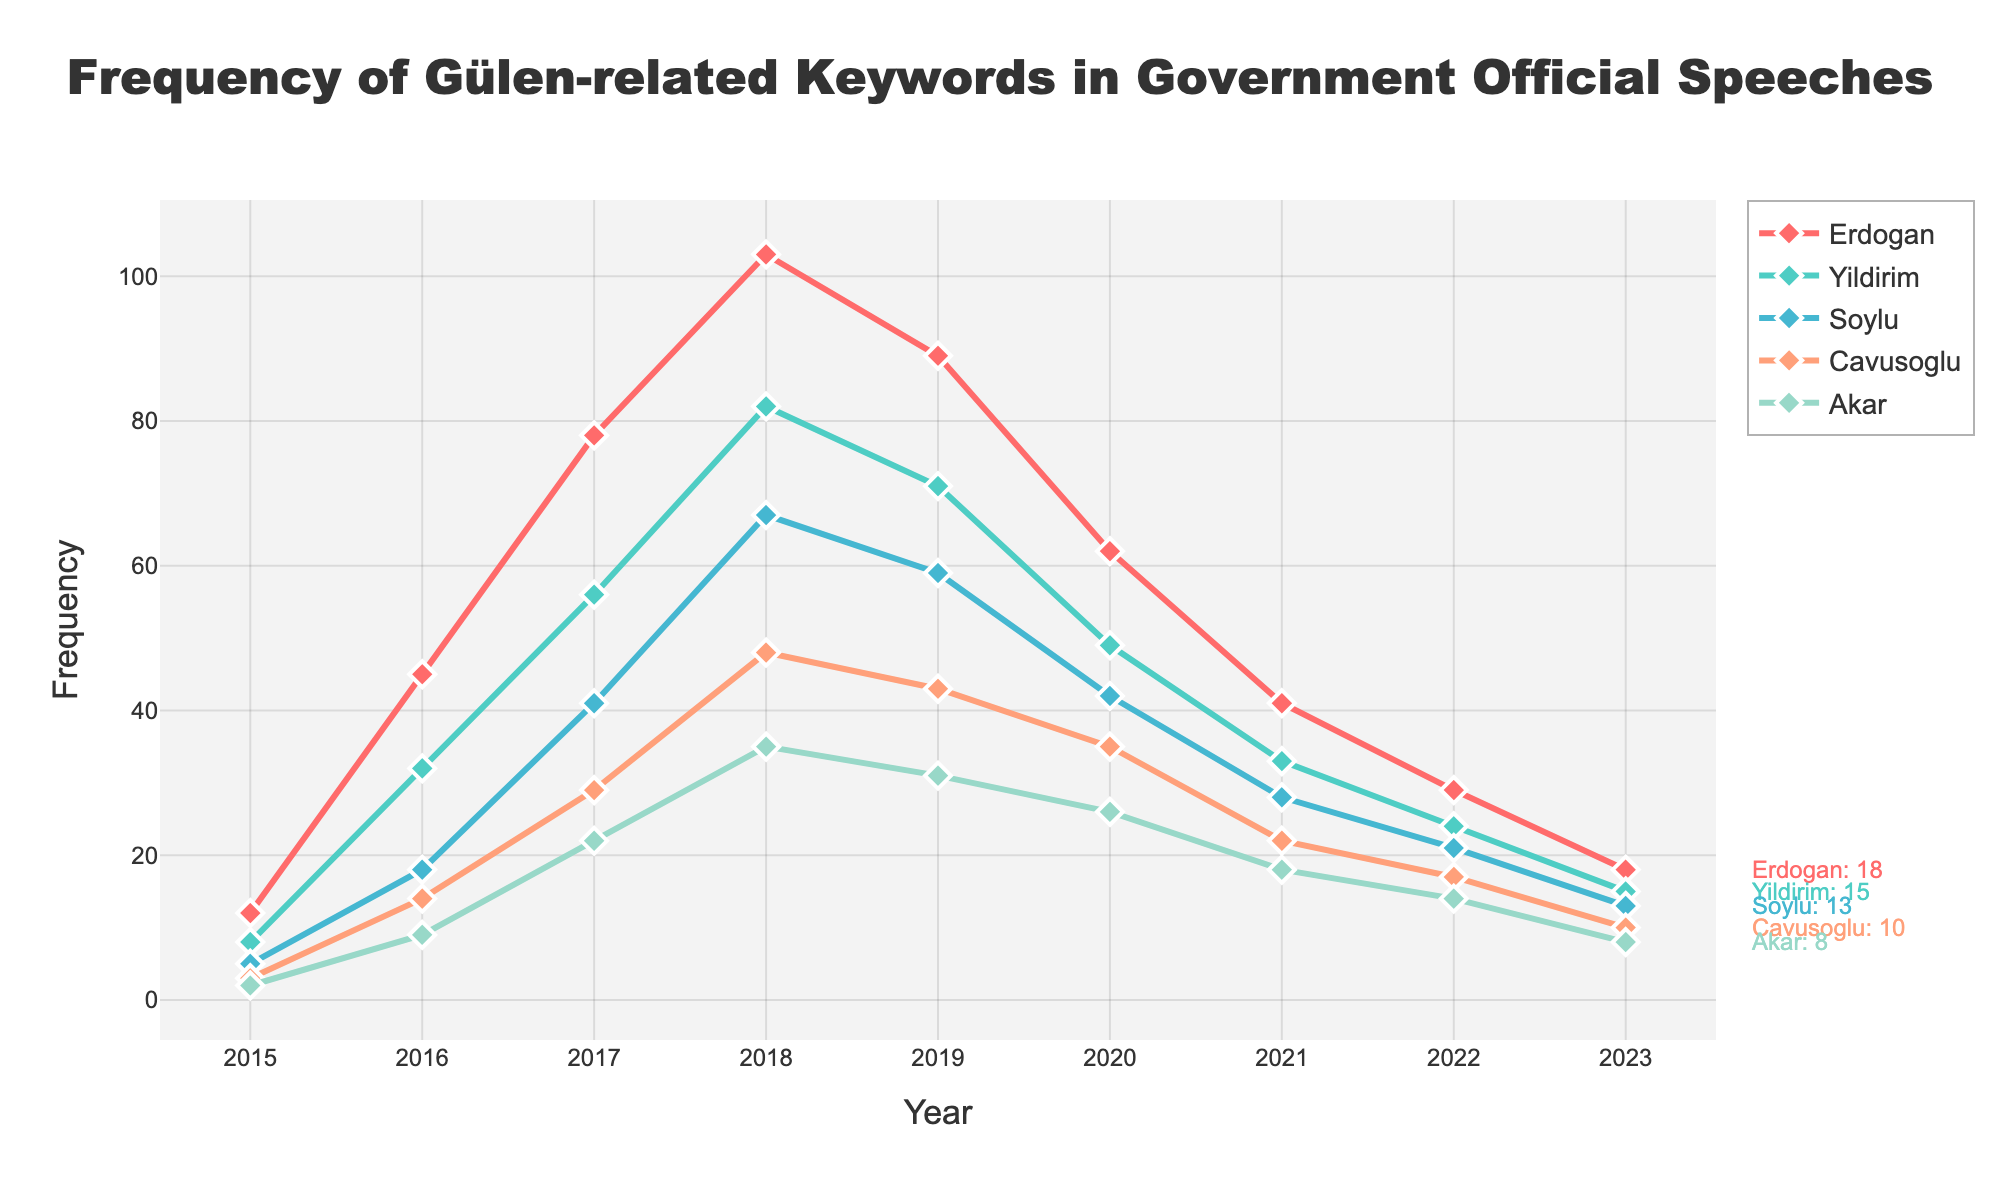What's the overall trend in the frequency of Gülen-related keywords in government official speeches from 2015 to 2023? The frequency of Gülen-related keywords increased from 2015 to 2018 before declining steadily from 2019 to 2023.
Answer: Increased till 2018, then declined Which official mentioned Gülen-related keywords the most in 2018? By looking at the highest point in the lines for 2018, we can see that Erdoğan mentioned Gülen-related keywords the most.
Answer: Erdoğan How did the frequency of Gülen-related keywords in Yıldırım's speeches change between 2015 and 2023? The frequency increased from 8 in 2015 to a peak of 82 in 2018, and then gradually declined to 15 by 2023.
Answer: Peaked in 2018, then declined Which year had the highest cumulative frequency of Gülen-related keywords across all officials? Summing the frequencies for each year and comparing them shows that 2018 had the highest cumulative frequency. (103+82+67+48+35) = 335 in 2018.
Answer: 2018 Who had a greater decline in the frequency of mentioning Gülen-related keywords from 2018 to 2023, Soylu or Çavuşoğlu? Soylu's frequency dropped from 67 to 13 (a decline of 54), while Çavuşoğlu's dropped from 48 to 10 (a decline of 38). So, Soylu had a greater decline.
Answer: Soylu What is the difference in the frequency of mentioning Gülen-related keywords between Erdoğan and Akar in 2020? In 2020, Erdoğan mentioned 62 times and Akar mentioned 26 times. The difference is 62 - 26 = 36.
Answer: 36 In which year did Erdoğan and Yıldırım have their closest frequencies of mentioning Gülen-related keywords? The closest difference occurs in 2019 where Erdoğan had 89 and Yıldırım had 71, giving a difference of 18.
Answer: 2019 What is the average frequency of Gülen-related keywords mentioned by Soylu from 2015 to 2023? Adding up Soylu's frequencies from 2015 to 2023 (5+18+41+67+59+42+28+21+13 = 294), then dividing by 9 years gives an average of 32.67.
Answer: 32.67 Which official had a decrease every consecutive year from 2018 to 2023 in the frequency of mentioning Gülen-related keywords? By examining each official's line from 2018 to 2023, Çavuşoğlu showed a yearly decrease: 48 to 43 to 35 to 22 to 17 to 10.
Answer: Çavuşoğlu 